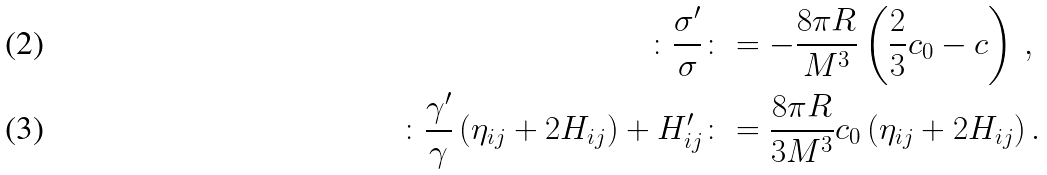<formula> <loc_0><loc_0><loc_500><loc_500>\colon \frac { \sigma ^ { \prime } } { \sigma } \colon & = - \frac { 8 \pi R } { M ^ { 3 } } \left ( \frac { 2 } { 3 } c _ { 0 } - c \right ) \, , \\ \colon \frac { \gamma ^ { \prime } } { \gamma } \left ( \eta _ { i j } + 2 H _ { i j } \right ) + H ^ { \prime } _ { i j } \colon & = \frac { 8 \pi R } { 3 M ^ { 3 } } c _ { 0 } \left ( \eta _ { i j } + 2 H _ { i j } \right ) .</formula> 